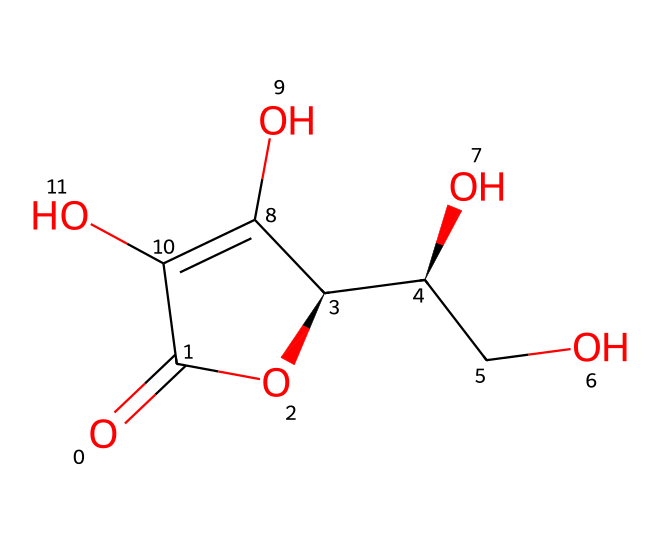What is the molecular formula of vitamin C based on its structure? To determine the molecular formula, we count the number of each type of atom in the SMILES representation: there are 6 carbon atoms, 8 hydrogen atoms, and 6 oxygen atoms. Therefore, the molecular formula is C6H8O6.
Answer: C6H8O6 How many hydroxyl (-OH) groups are present in the structure? By analyzing the chemical structure, we can identify the hydroxyl groups, which are connected to carbon atoms. There are four distinct -OH groups present in the structure.
Answer: 4 Is vitamin C a saturated or unsaturated compound? To assess whether a compound is saturated or unsaturated, we need to look for double bonds. The presence of a double bond in the ring structure indicates that vitamin C is an unsaturated compound.
Answer: unsaturated What functional group is mainly responsible for the antioxidant properties of vitamin C? The antioxidant properties of vitamin C are primarily attributed to the presence of the enediol functional group, which allows it to donate electrons easily, helping neutralize free radicals.
Answer: enediol What type of chemical structure does vitamin C have? Vitamin C has a cyclic structure due to the presence of a ring in its chemical composition. This structural feature helps determine its chemical properties and reactivity.
Answer: cyclic How many rings are present in the structure of vitamin C? In the given SMILES representation, there is one cyclic segment which indicates that there is one ring present in the structure of vitamin C.
Answer: 1 What is the significance of ascorbic acid being a reducing agent? Ascorbic acid, or vitamin C, acts as a reducing agent because it can donate electrons in redox reactions, which is crucial for its role as an antioxidant in the body, helping to protect cells from damage.
Answer: reducing agent 